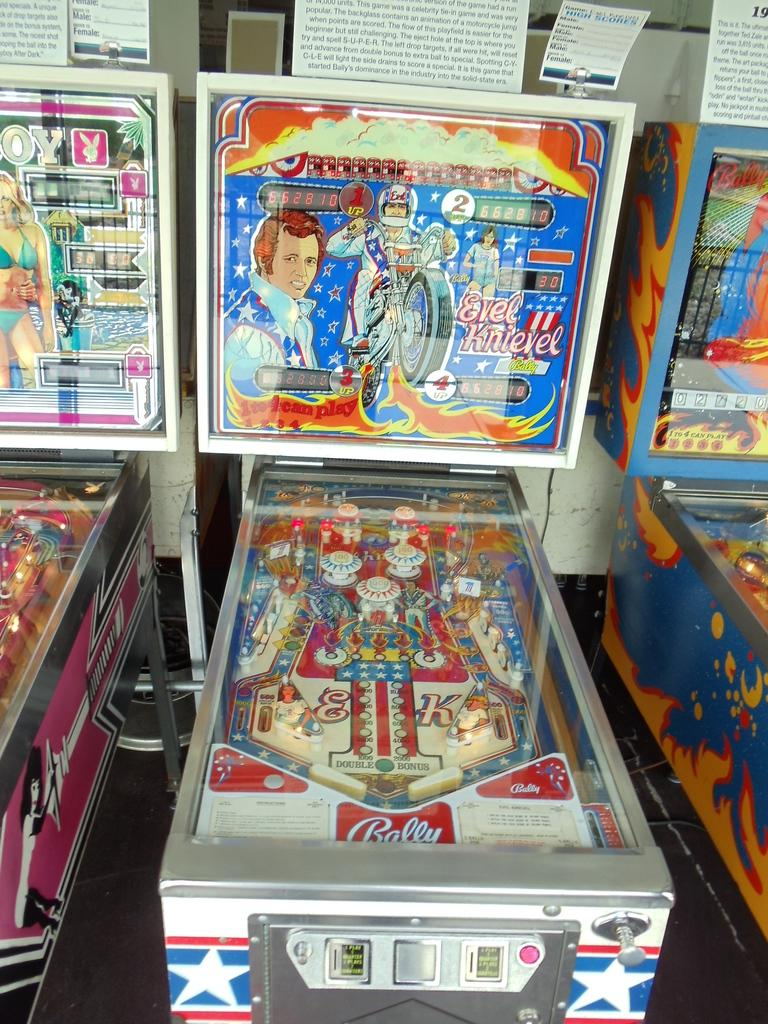Provide a one-sentence caption for the provided image. An Evel Knievel pinball machine, made by Bally, sits in a row of other pinball machines. 